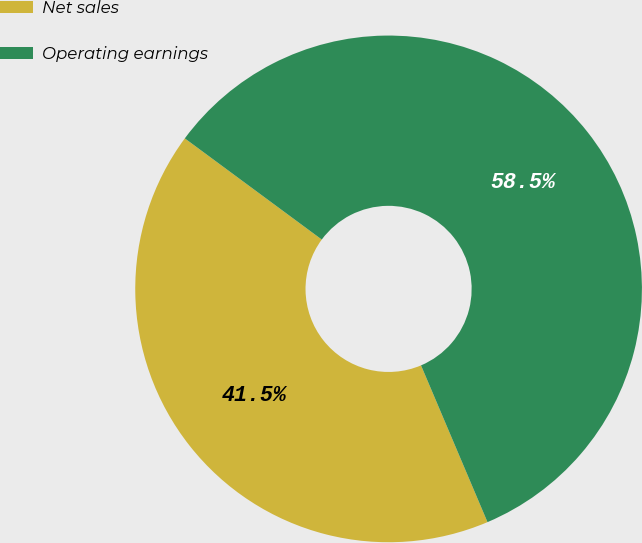Convert chart to OTSL. <chart><loc_0><loc_0><loc_500><loc_500><pie_chart><fcel>Net sales<fcel>Operating earnings<nl><fcel>41.51%<fcel>58.49%<nl></chart> 